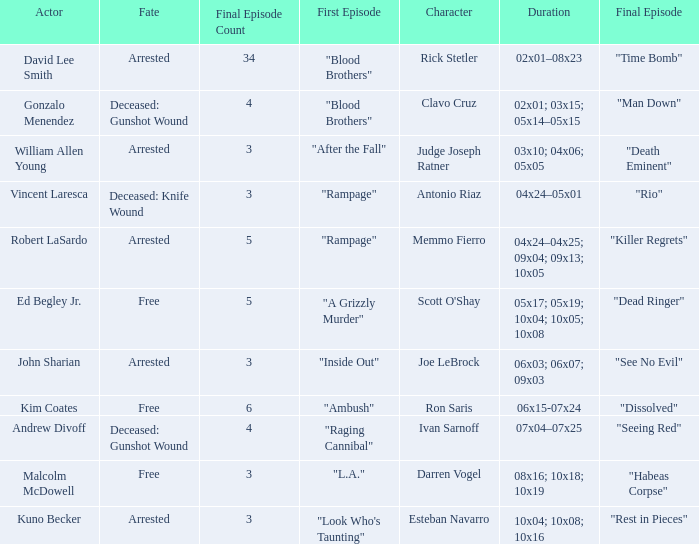Which performers appear in the first episode named "ambush"? Kim Coates. 